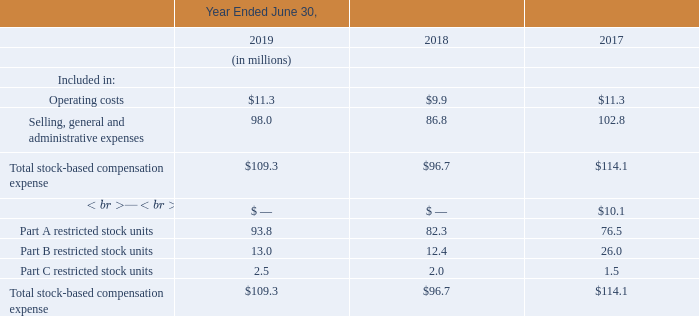(11) STOCK-BASED COMPENSATION
The following tables summarize the Company’s stock-based compensation expense for liability and equity classified awards included in the consolidated statements of operations:
CII Common and Preferred Units
Prior to the Company’s IPO, the Company was given authorization by Communications Infrastructure Investments, LLC (“CII”) to award 625,000,000 of CII’s common units as profits interests to employees, directors, and affiliates of the Company. The common units were historically considered to be stock-based compensation with terms that required the awards to be classified as liabilities due to cash settlement features. The vested portion of the awards was reported as a liability and the fair value was re-measured at each reporting date until the date of settlement, with a corresponding charge (or credit) to stock-based compensation expense. On December 31, 2016, the CII common units became fully vested and as such there is no remaining unrecognized compensation cost associated with CII common units for any period subsequent to December 31, 2016.
The value of the CII common units was derived from the value of CII’s investments in the Company and Onvoy, LLC and its subsidiaries (“OVS”), a company that provided voice and managed services which the Company spun off during the year ended June 30, 2014. As the value derived from each of these investments was separately determinable and there was a plan in place to distribute the value associated with the investment in Company shares separate from the value derived from OVS, the two components were accounted for separately. The OVS component of the CII awards was adjusted to fair value each reporting period. On December 31, 2015, CII entered into an agreement to sell OVS to a third party. The sale was completed in May 2016. Based on the sale price, the estimated fair value of OVS awards was increased, resulting in an increase to stock based compensation expense and corresponding increase to additional paid-in capital of $12.9 million for the year ended June 30, 2016. Proceeds from the sale to be distributed to the Company’s employees was paid by CII.
When did the CII common units become fully vested? December 31, 2016. How many of CII's common units were awarded as profit interests to employees, directors and affiliates of the company? 625,000,000. What does the following table summarize? The following tables summarize the company’s stock-based compensation expense for liability and equity classified awards included in the consolidated statements of operations:. Which of the years saw a total stock-based compensation expense of more than 100 million? 114.1 > 100 ## 109.3 > 100
Answer: 2017, 2019. Which of the years had the highest selling, general and administrative expenses? 102.8 > 98.0 >86.8
Answer: 2017. What were the total operating costs for all 3 years?
Answer scale should be: million. 11.3 + 9.9 + 11.3
Answer: 32.5. 